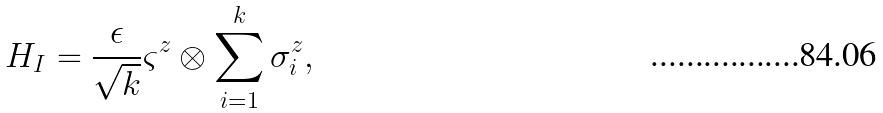Convert formula to latex. <formula><loc_0><loc_0><loc_500><loc_500>H _ { I } = \frac { \epsilon } { \sqrt { k } } \varsigma ^ { z } \otimes \sum _ { i = 1 } ^ { k } { \sigma _ { i } ^ { z } } ,</formula> 